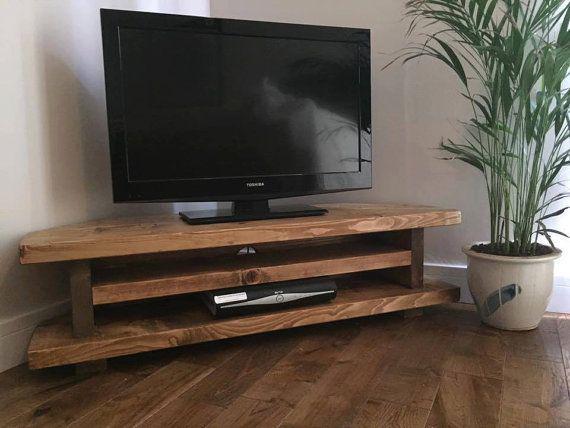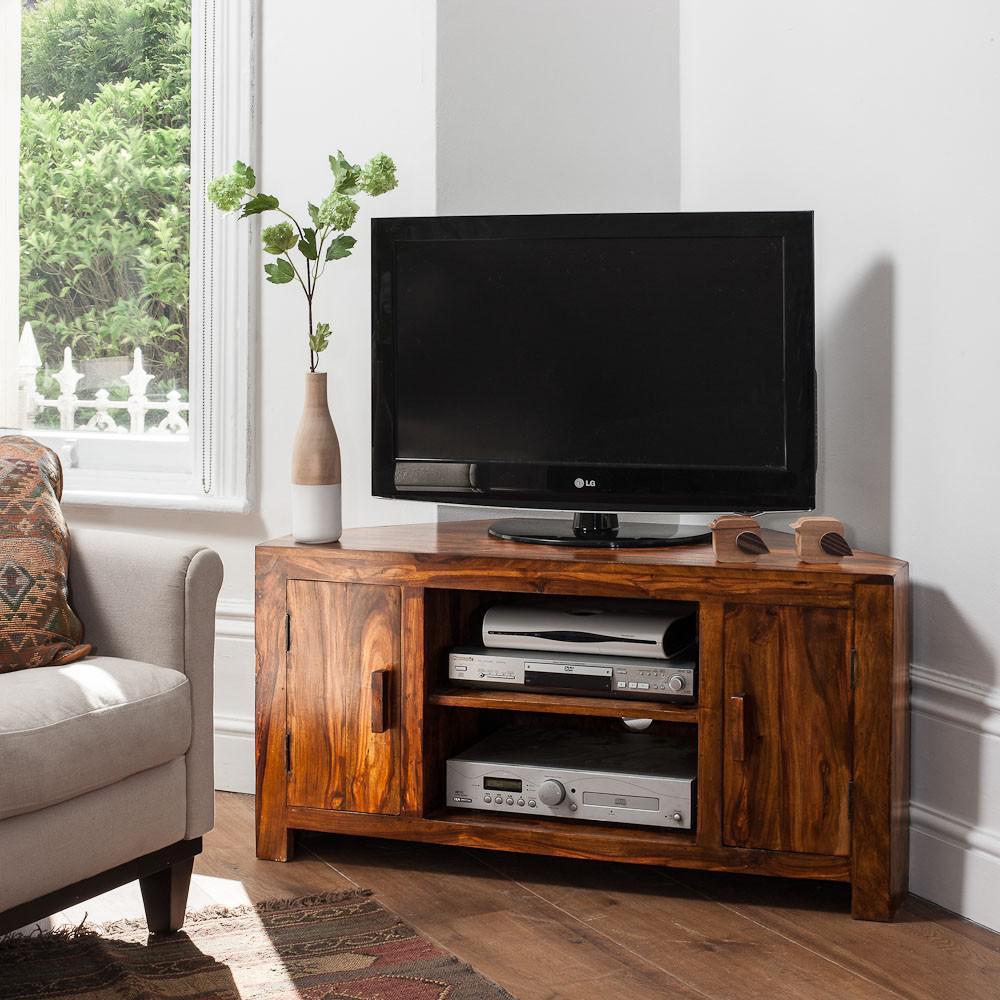The first image is the image on the left, the second image is the image on the right. For the images displayed, is the sentence "The legs of one media stand is made of metal." factually correct? Answer yes or no. No. The first image is the image on the left, the second image is the image on the right. For the images displayed, is the sentence "Both TVs have black frames." factually correct? Answer yes or no. Yes. 